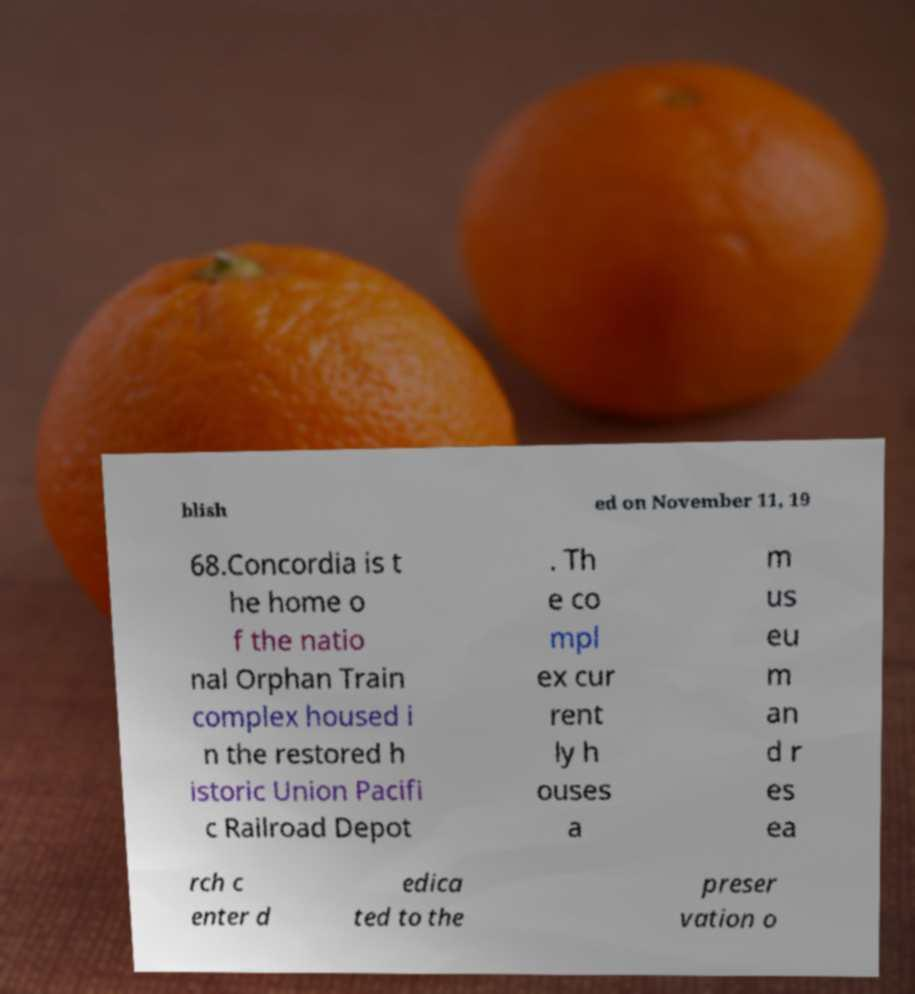Can you read and provide the text displayed in the image?This photo seems to have some interesting text. Can you extract and type it out for me? blish ed on November 11, 19 68.Concordia is t he home o f the natio nal Orphan Train complex housed i n the restored h istoric Union Pacifi c Railroad Depot . Th e co mpl ex cur rent ly h ouses a m us eu m an d r es ea rch c enter d edica ted to the preser vation o 